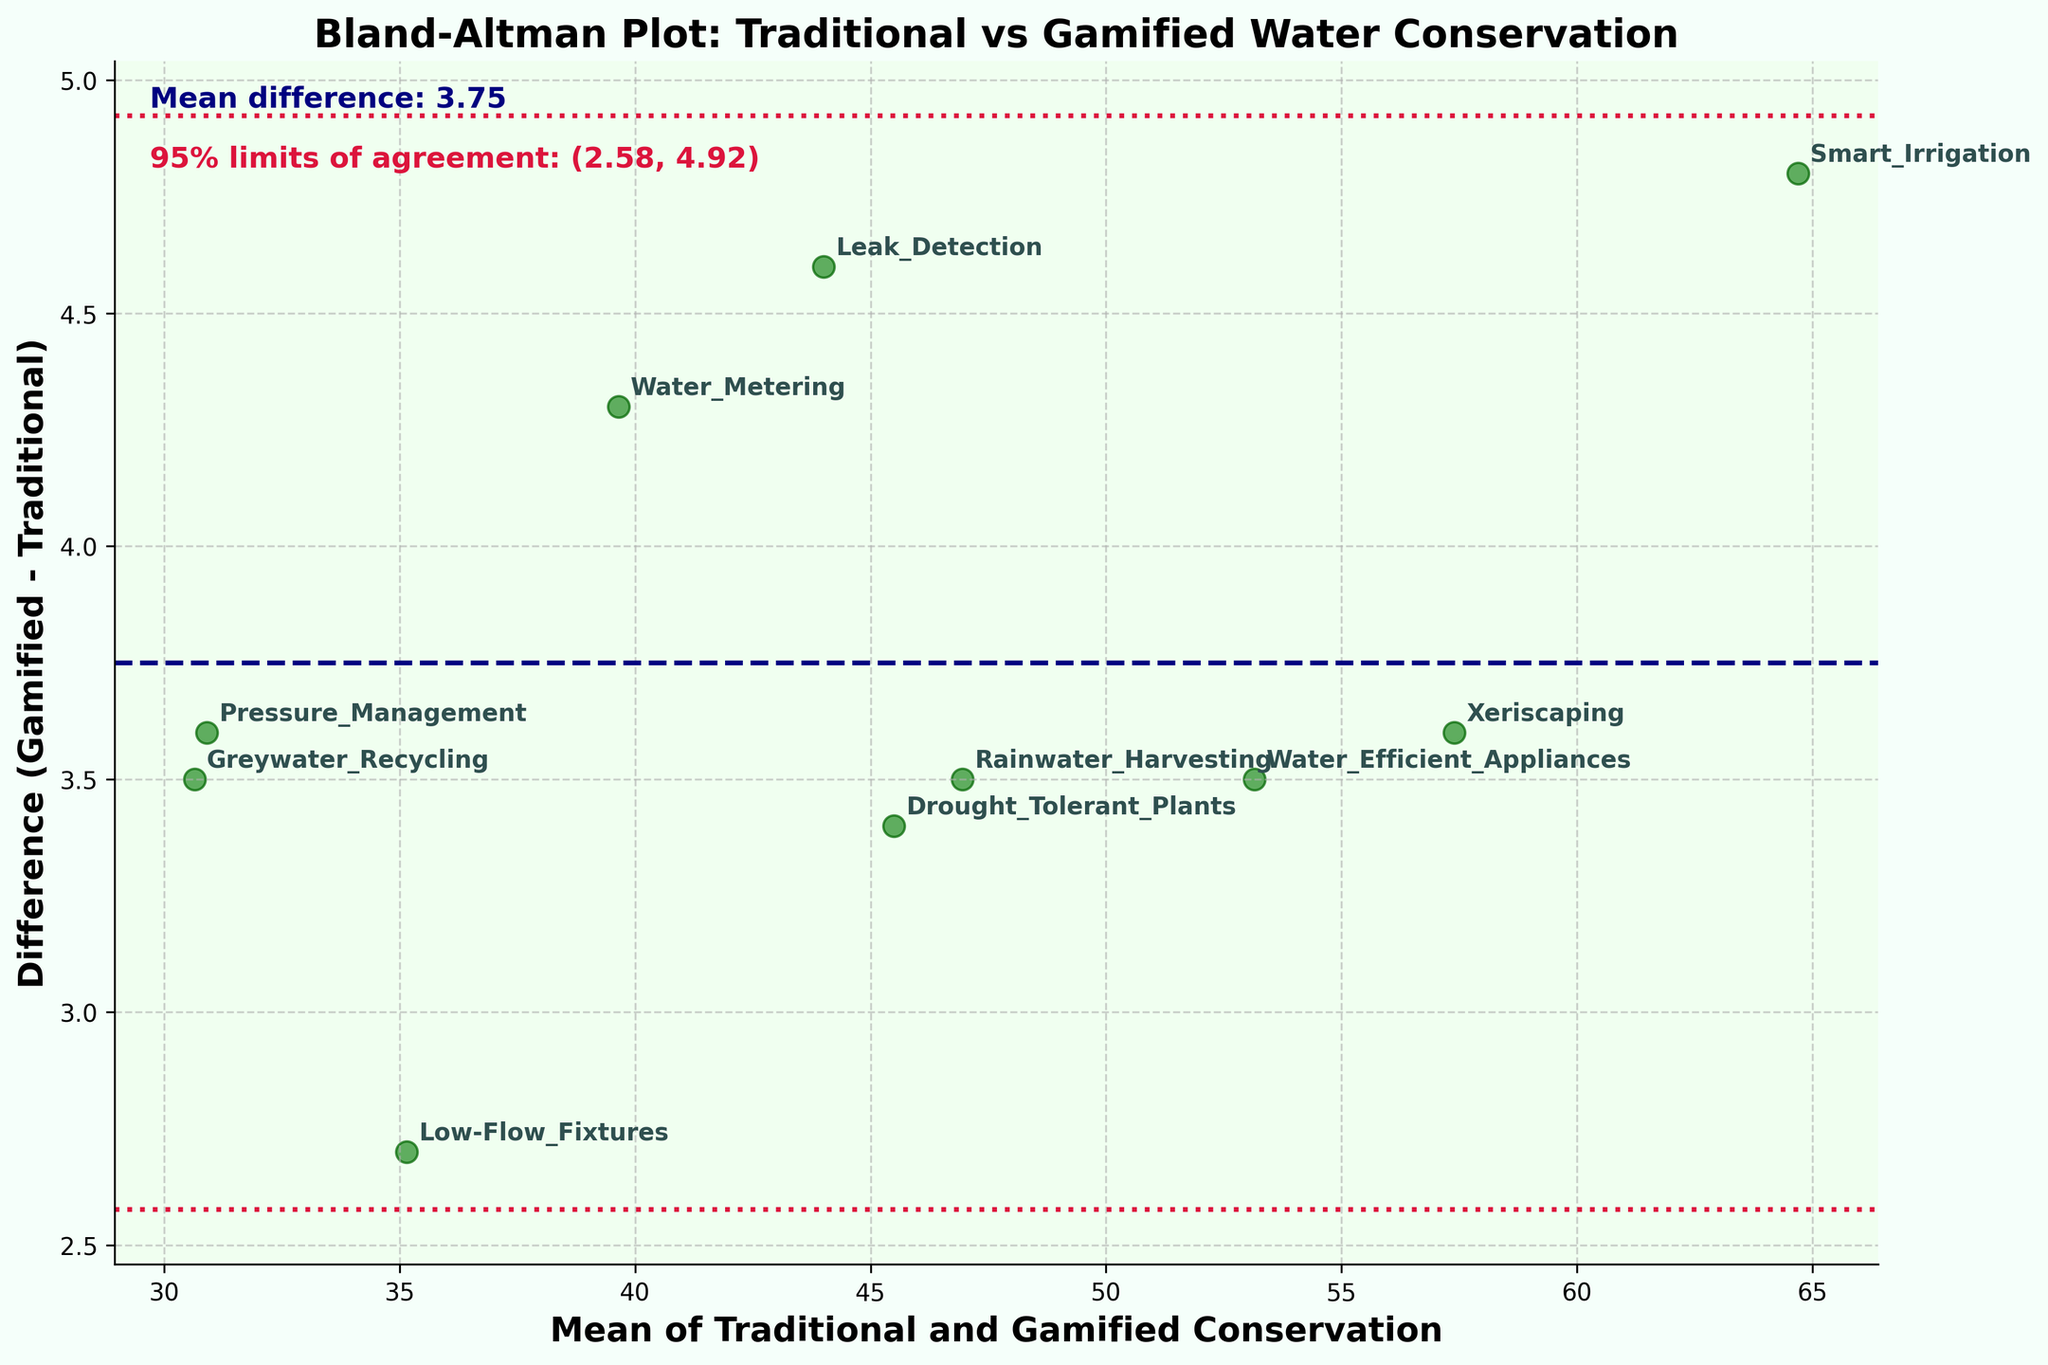What is the title of the plot? The title is usually located at the top of the plot and gives a summary of what the plot represents. In this case, the title provides the context of the data being compared.
Answer: Bland-Altman Plot: Traditional vs Gamified Water Conservation What are the x-axis and y-axis labels? The axis labels define what each axis represents. The x-axis label specifies what the values on the horizontal axis are, while the y-axis label specifies what the values on the vertical axis are.
Answer: Mean of Traditional and Gamified Conservation and Difference (Gamified - Traditional) How many data points are presented in the plot? Each data point corresponds to a pair of measurements, and they are represented as individual markers on the plot. We can count these markers directly.
Answer: 10 Which method shows the largest difference between gamified and traditional conservation techniques? We need to look for the point on the y-axis that has the highest value (greatest difference).
Answer: Smart Irrigation What is the mean difference between the gamified and traditional conservation techniques? The mean difference is usually represented by a horizontal line across the plot and labeled.
Answer: 3.9 What are the 95% limits of agreement for the differences? The 95% limits of agreement are shown by two dashed lines above and below the mean difference line. These are often labeled on the plot.
Answer: (2.66, 5.14) Which method(s) lie outside the 95% limits of agreement? To answer this, we look for any points that fall outside the upper or lower dashed lines that represent the 95% limits of agreement.
Answer: None Between which two water conservation methods is the difference in conservation techniques the smallest? We compare the y-values (differences) of all methods and identify the smallest difference.
Answer: Low-Flow Fixtures and Drought Tolerant Plants What is the color used to represent the data points? The color of the points provides a visual distinction and is generally chosen to stand out against the plot background.
Answer: Forest green How does the plot visually distinguish the mean difference line from the 95% limits of agreement lines? This can be determined by examining the visual styles (color, linestyle) of the lines on the plot.
Answer: The mean difference line is navy and dashed, while the 95% limits of agreement lines are crimson and dotted 